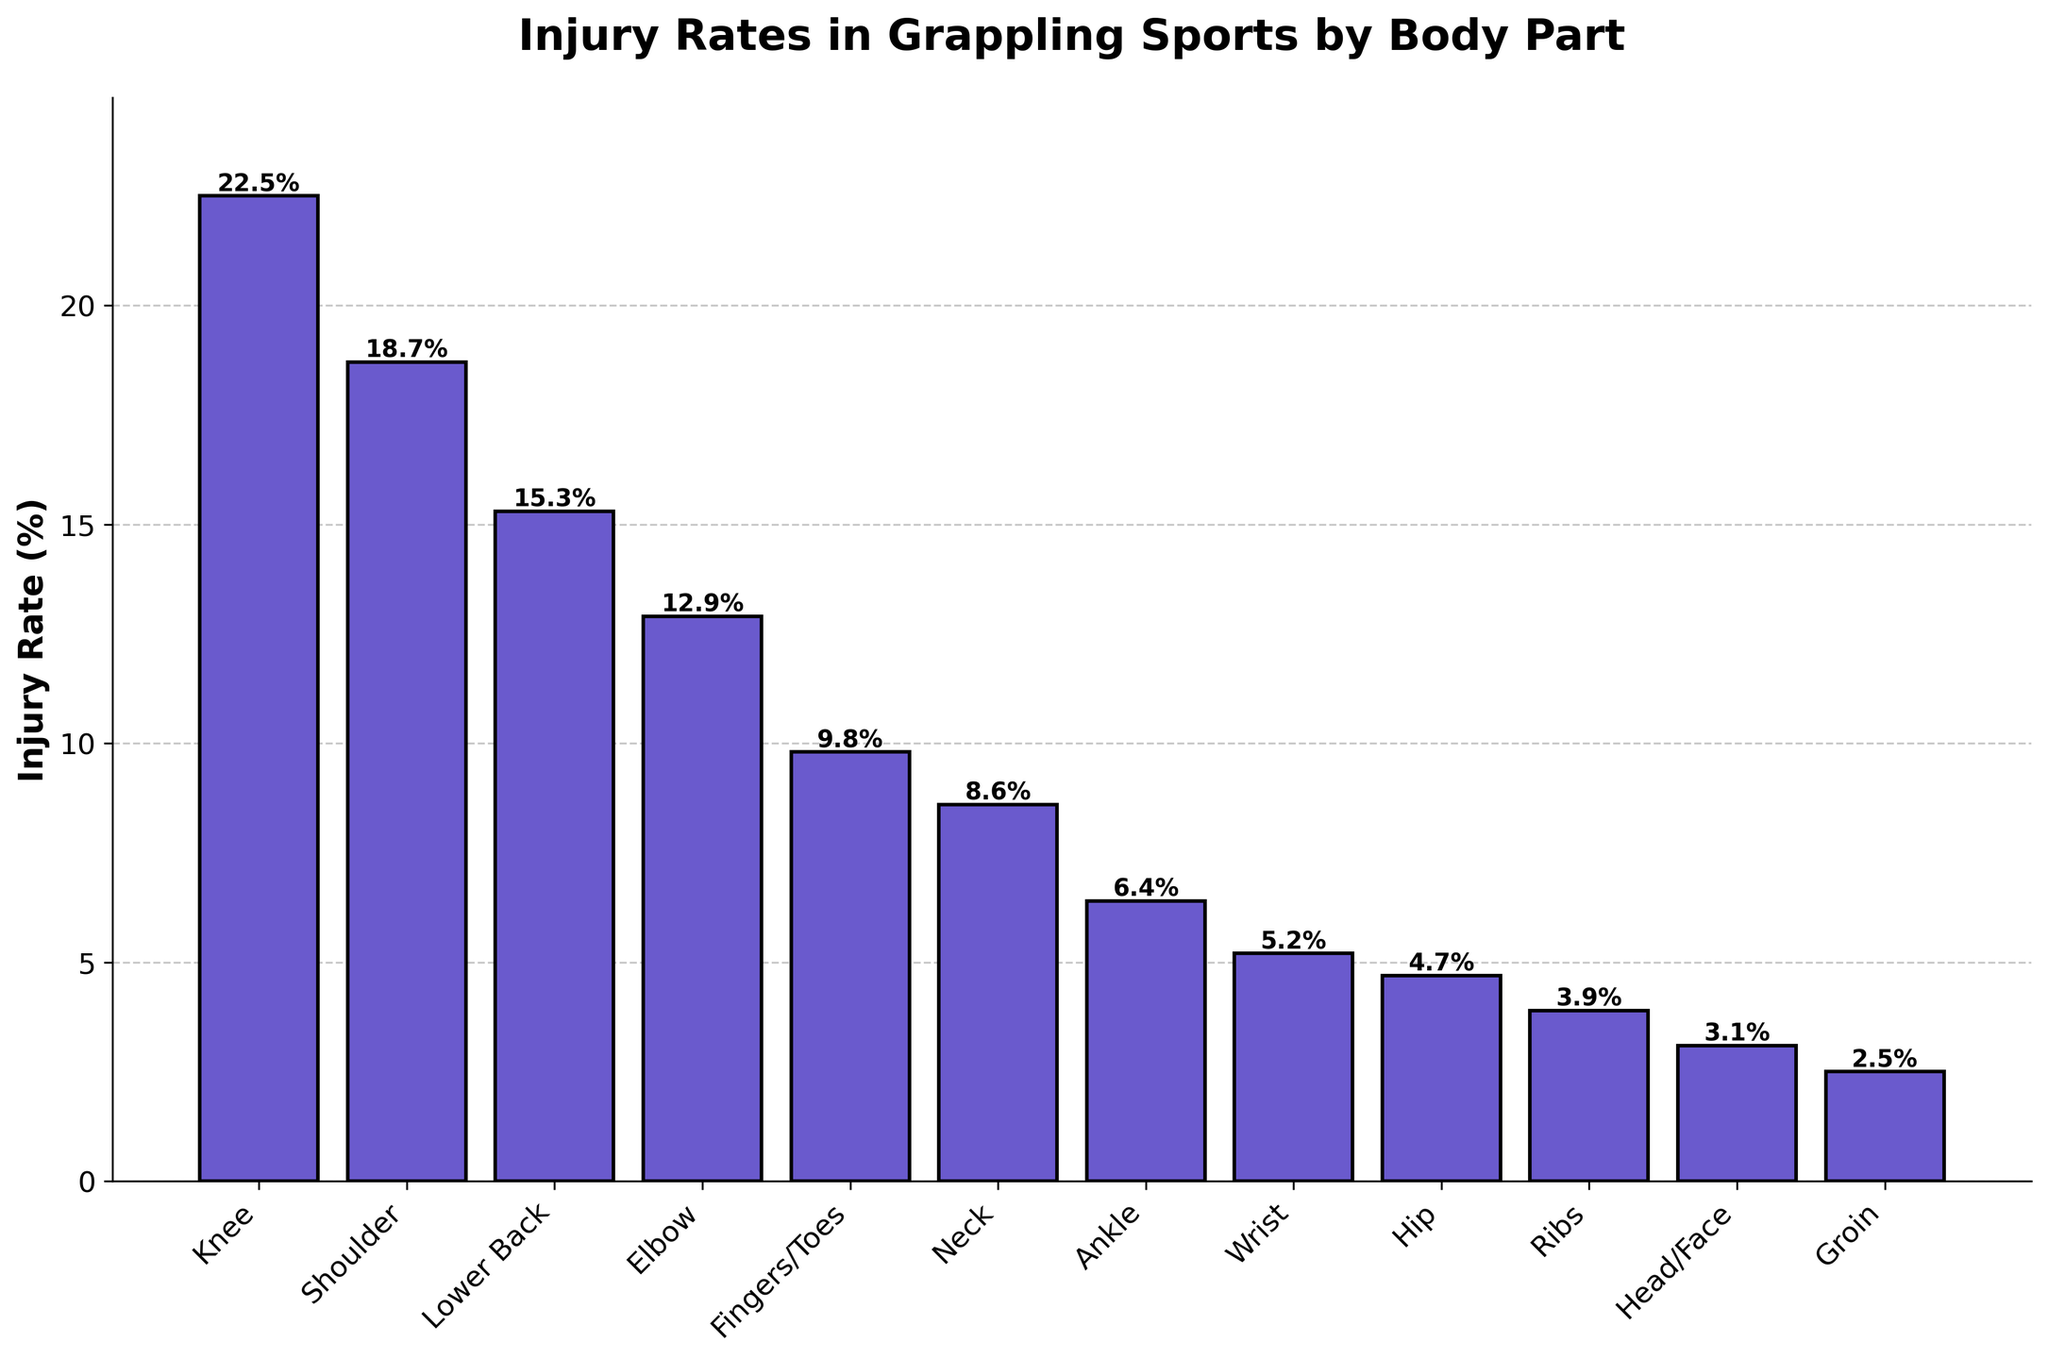Which body part has the highest injury rate? The bar representing the knee is the tallest among all bars, indicating the highest injury rate.
Answer: Knee What is the combined injury rate percentage for the knee and shoulder? Add the injury rate of the knee (22.5%) to the injury rate of the shoulder (18.7%): 22.5 + 18.7 = 41.2%.
Answer: 41.2% Which body part has a lower injury rate, the ankle or the wrist? Compare the heights of the bars for the ankle (6.4%) and the wrist (5.2%). The wrist bar is shorter than the ankle bar.
Answer: Wrist How much taller is the bar for the lower back compared to the bar for the elbow? Subtract the injury rate of the elbow (12.9%) from the injury rate of the lower back (15.3%): 15.3 - 12.9 = 2.4%.
Answer: 2.4% What is the average injury rate for the hip, ribs, and head/face? Add the injury rates of the hip (4.7%), ribs (3.9%), and head/face (3.1%), then divide by 3: (4.7 + 3.9 + 3.1) / 3 = 3.9%.
Answer: 3.9% Which body parts have injury rates less than 10%? Identify bars with heights representing less than 10%: fingers/toes (9.8%), neck (8.6%), ankle (6.4%), wrist (5.2%), hip (4.7%), ribs (3.9%), head/face (3.1%), groin (2.5%).
Answer: Fingers/Toes, Neck, Ankle, Wrist, Hip, Ribs, Head/Face, Groin What is the difference in injury rates between the shoulder and the wrist? Subtract the injury rate of the wrist (5.2%) from the injury rate of the shoulder (18.7%): 18.7 - 5.2 = 13.5%.
Answer: 13.5% Which body part has an injury rate closest to 5%? Compare injury rates and find the bar closest to 5%: wrist (5.2%) is closest.
Answer: Wrist Rank the top three body parts with the highest injury rates. Identify and order the three tallest bars: knee (22.5%), shoulder (18.7%), and lower back (15.3%).
Answer: Knee, Shoulder, Lower Back What is the combined injury rate percentage for the head/face and groin? Add the injury rate of the head/face (3.1%) to the injury rate of the groin (2.5%): 3.1 + 2.5 = 5.6%.
Answer: 5.6% 